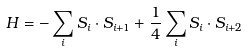<formula> <loc_0><loc_0><loc_500><loc_500>H = - \sum _ { i } { S } _ { i } \cdot { S } _ { i + 1 } + \frac { 1 } { 4 } \sum _ { i } { S } _ { i } \cdot { S } _ { i + 2 }</formula> 